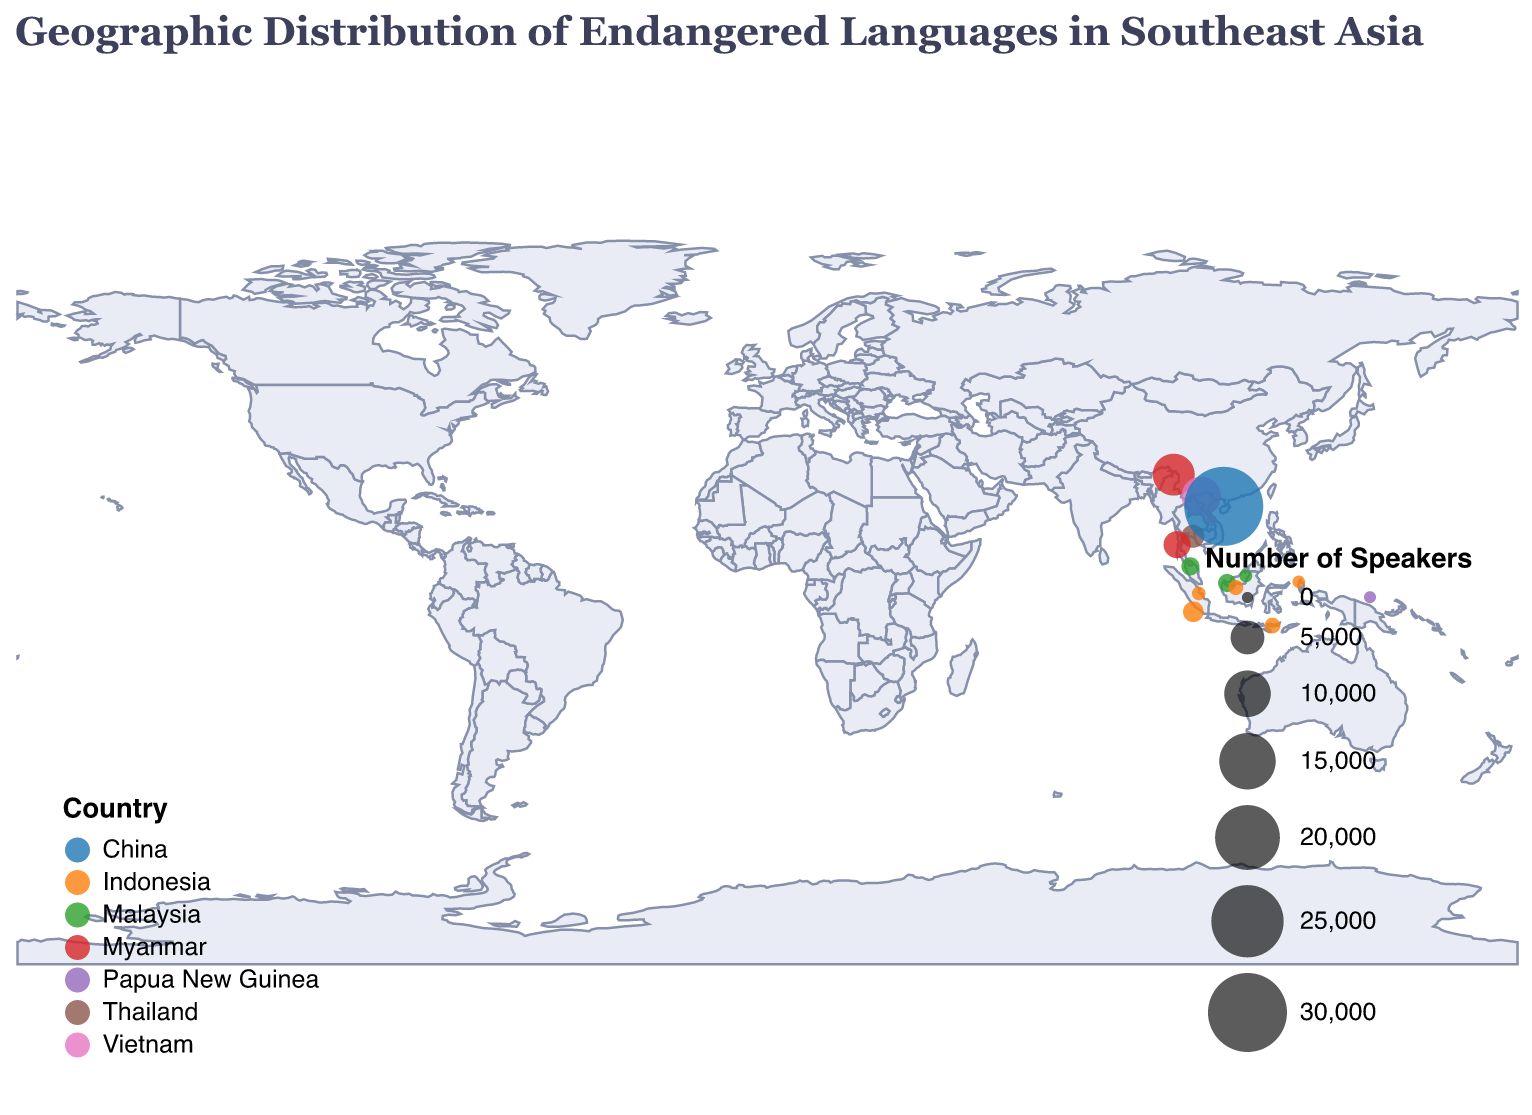What's the title of the plot? The title is located at the top of the figure and provides a brief description of what the plot represents.
Answer: Geographic Distribution of Endangered Languages in Southeast Asia Which country has the language with the highest number of speakers? By looking at the size of circles and the legend indicating the number of speakers, the largest circle corresponds to the "Ong Be" language in China, which has 30,000 speakers.
Answer: China How many languages are spoken in Indonesia according to the figure? By counting the distinct language markers (circles) located within the borders of Indonesia, we identify 7 languages: Duano, Enggano, Gorap, Hovongan, Ndrulo, and Punan Batu.
Answer: 6 What is the average number of speakers across all languages? To find the average number of speakers, sum up the total number of speakers from all languages and divide by the total number of languages. The total speakers are (50+1000+2000+300+1500+150+500+8000+1000+100+7000+3000+600+30000+200) = 54,400. There are 15 languages, so the average is 54,400 / 15.
Answer: 3,627 Which language is spoken at the most northern latitude? By observing the latitude values, the language "Idu" in Myanmar has the highest latitude of 27.5, making it the most northern.
Answer: Idu How many languages are there in Malaysia, and what are they? By identifying the data points located within Malaysia, we see 4 languages: Biatah, Jahai, and Punan Batu.
Answer: 3 (Biatah, Jahai, Punan Batu) Which language has the smallest number of speakers, and in which country is it located? Observing the size of the circles and number of speakers listed in the tooltip, "Arem" in Vietnam has the smallest number of speakers with only 50.
Answer: Arem, Vietnam Compare the number of languages spoken in Indonesia and Malaysia. Which country has more endangered languages? By counting the number of languages (circles) located in each country, Indonesia has 6 languages while Malaysia has 3. Indonesia has more endangered languages.
Answer: Indonesia What is the total number of speakers for languages spoken in Vietnam? Summing up the number of speakers for the languages spoken in Vietnam: Arem (50) and Lachi (7000), the total is 50 + 7000.
Answer: 7,050 Which country has the second highest number of languages and how many? Reviewing the number of language markers per country, Indonesia has the highest with 6 languages, Malaysia follows with 3 languages.
Answer: Malaysia, 3 